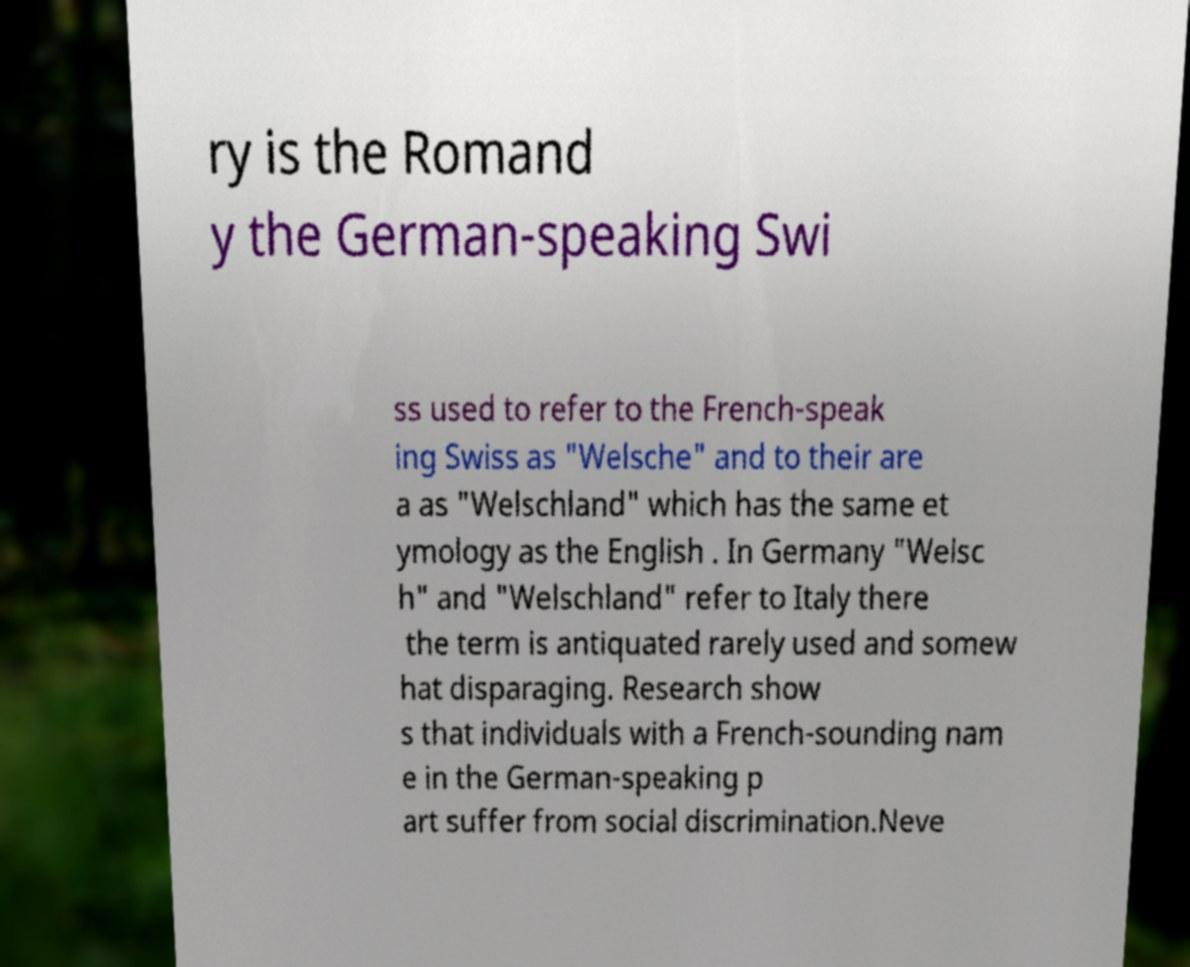There's text embedded in this image that I need extracted. Can you transcribe it verbatim? ry is the Romand y the German-speaking Swi ss used to refer to the French-speak ing Swiss as "Welsche" and to their are a as "Welschland" which has the same et ymology as the English . In Germany "Welsc h" and "Welschland" refer to Italy there the term is antiquated rarely used and somew hat disparaging. Research show s that individuals with a French-sounding nam e in the German-speaking p art suffer from social discrimination.Neve 